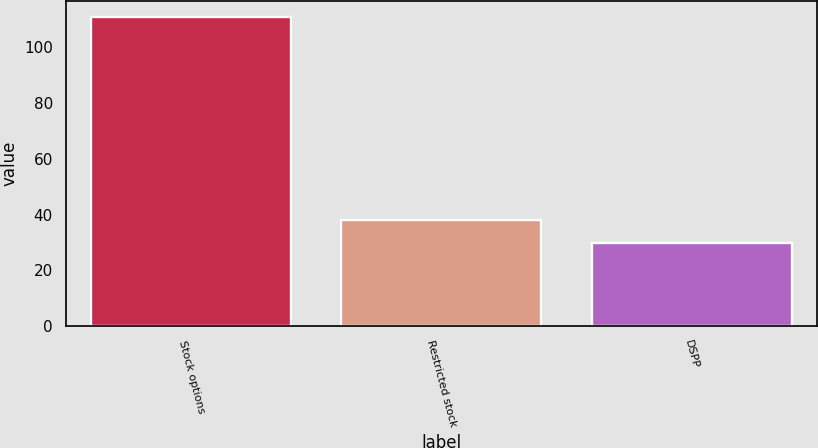Convert chart. <chart><loc_0><loc_0><loc_500><loc_500><bar_chart><fcel>Stock options<fcel>Restricted stock<fcel>DSPP<nl><fcel>111<fcel>38.1<fcel>30<nl></chart> 